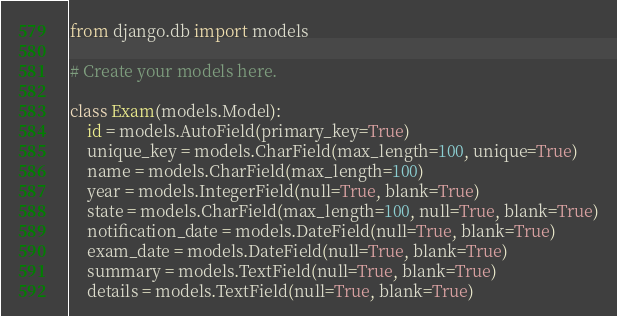Convert code to text. <code><loc_0><loc_0><loc_500><loc_500><_Python_>from django.db import models

# Create your models here.

class Exam(models.Model):
    id = models.AutoField(primary_key=True)
    unique_key = models.CharField(max_length=100, unique=True)
    name = models.CharField(max_length=100)
    year = models.IntegerField(null=True, blank=True)
    state = models.CharField(max_length=100, null=True, blank=True)
    notification_date = models.DateField(null=True, blank=True)
    exam_date = models.DateField(null=True, blank=True)
    summary = models.TextField(null=True, blank=True)
    details = models.TextField(null=True, blank=True)</code> 